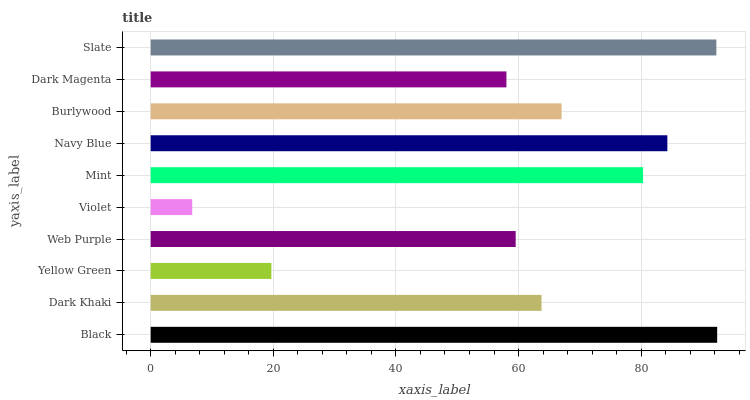Is Violet the minimum?
Answer yes or no. Yes. Is Black the maximum?
Answer yes or no. Yes. Is Dark Khaki the minimum?
Answer yes or no. No. Is Dark Khaki the maximum?
Answer yes or no. No. Is Black greater than Dark Khaki?
Answer yes or no. Yes. Is Dark Khaki less than Black?
Answer yes or no. Yes. Is Dark Khaki greater than Black?
Answer yes or no. No. Is Black less than Dark Khaki?
Answer yes or no. No. Is Burlywood the high median?
Answer yes or no. Yes. Is Dark Khaki the low median?
Answer yes or no. Yes. Is Dark Khaki the high median?
Answer yes or no. No. Is Mint the low median?
Answer yes or no. No. 